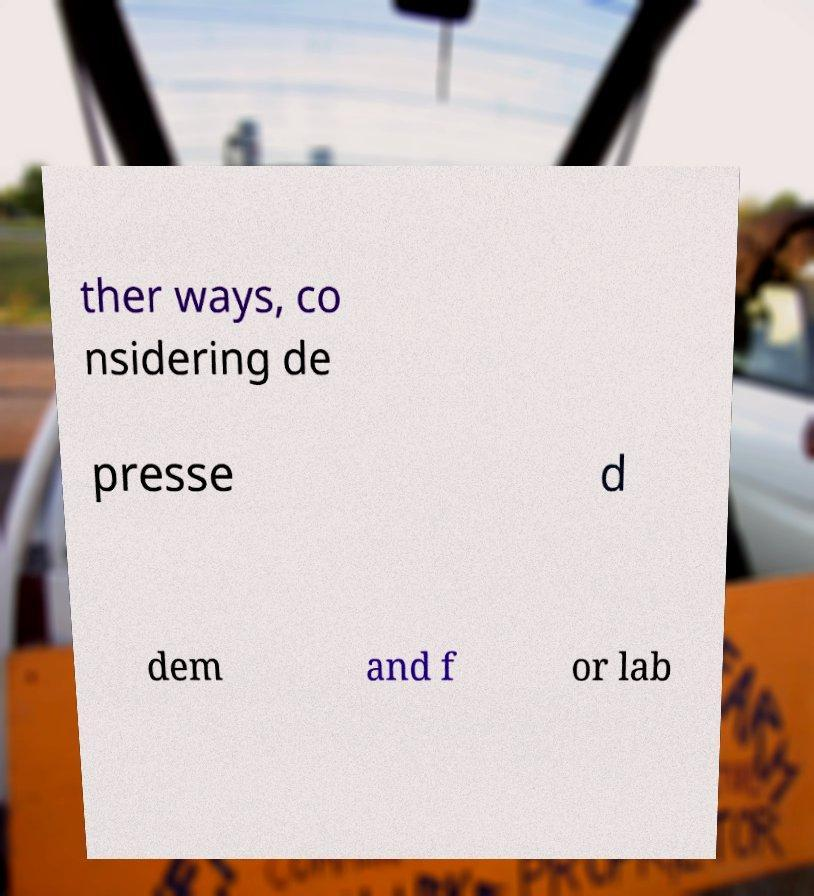I need the written content from this picture converted into text. Can you do that? ther ways, co nsidering de presse d dem and f or lab 